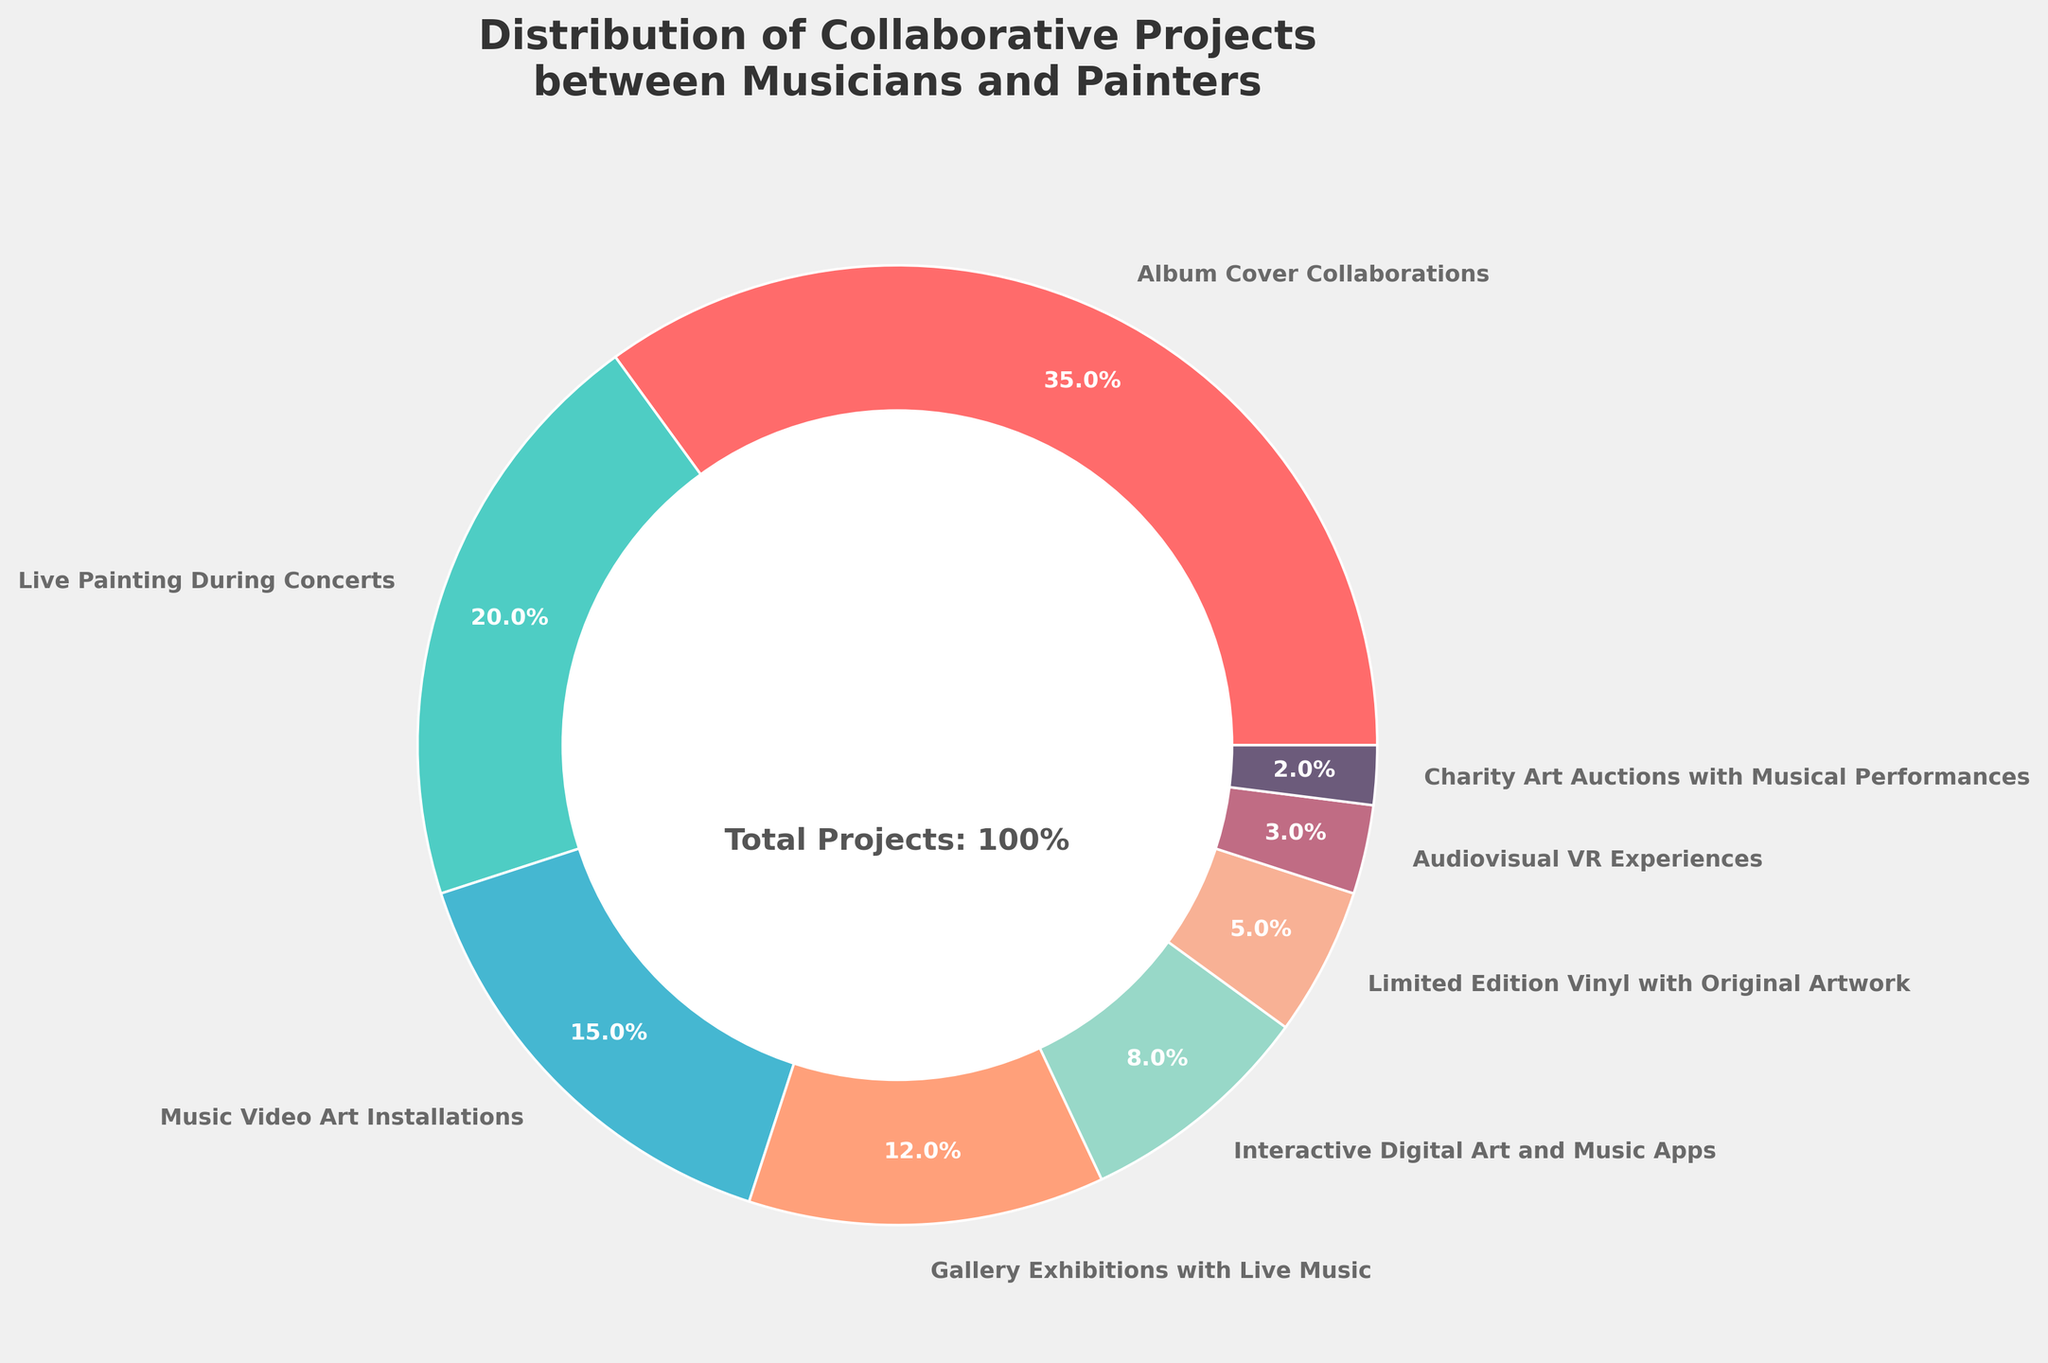Which project type has the highest percentage? The pie chart shows different project types with their respective percentages. By examining the chart, we see that "Album Cover Collaborations" has the largest segment.
Answer: Album Cover Collaborations What is the combined percentage of "Music Video Art Installations" and "Live Painting During Concerts"? To find the combined percentage, we add the percentages of the two project types: 15% (Music Video Art Installations) + 20% (Live Painting During Concerts) = 35%.
Answer: 35% Which project type represents the smallest portion of the pie chart? The pie chart shows that "Charity Art Auctions with Musical Performances" has the smallest segment, representing 2% of the total.
Answer: Charity Art Auctions with Musical Performances Does "Gallery Exhibitions with Live Music" have a higher or lower percentage than "Interactive Digital Art and Music Apps"? By comparing the segments, "Gallery Exhibitions with Live Music" has 12%, which is higher than 8% for "Interactive Digital Art and Music Apps".
Answer: Higher What is the difference in percentage between "Limited Edition Vinyl with Original Artwork" and "Audiovisual VR Experiences"? Subtract the percentage of "Audiovisual VR Experiences" from "Limited Edition Vinyl with Original Artwork": 5% - 3% = 2%.
Answer: 2% How do "Album Cover Collaborations" and "Live Painting During Concerts" visually differ in the pie chart? "Album Cover Collaborations" has the largest segment with a vibrant color, while "Live Painting During Concerts" has a slightly smaller segment with a different color. Both are distinctly separated and easily distinguishable by their colors and sizes.
Answer: Largest vs Smaller Segment What is the average percentage of the given project types? Calculate the average by summing up all the percentages and dividing by the number of project types: (35 + 20 + 15 + 12 + 8 + 5 + 3 + 2) / 8 = 12.5%.
Answer: 12.5% Which project types have a combined percentage equal to "Album Cover Collaborations"? "Album Cover Collaborations" is 35%. The combined percentage of "Music Video Art Installations" (15%) and "Live Painting During Concerts" (20%) is 35%. Hence, these two types together match the percentage of "Album Cover Collaborations".
Answer: Music Video Art Installations and Live Painting During Concerts 